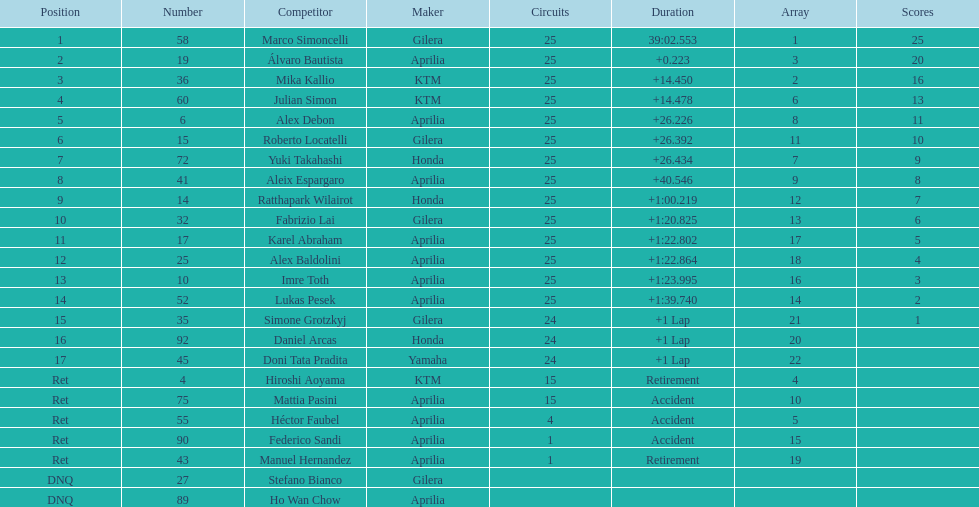I'm looking to parse the entire table for insights. Could you assist me with that? {'header': ['Position', 'Number', 'Competitor', 'Maker', 'Circuits', 'Duration', 'Array', 'Scores'], 'rows': [['1', '58', 'Marco Simoncelli', 'Gilera', '25', '39:02.553', '1', '25'], ['2', '19', 'Álvaro Bautista', 'Aprilia', '25', '+0.223', '3', '20'], ['3', '36', 'Mika Kallio', 'KTM', '25', '+14.450', '2', '16'], ['4', '60', 'Julian Simon', 'KTM', '25', '+14.478', '6', '13'], ['5', '6', 'Alex Debon', 'Aprilia', '25', '+26.226', '8', '11'], ['6', '15', 'Roberto Locatelli', 'Gilera', '25', '+26.392', '11', '10'], ['7', '72', 'Yuki Takahashi', 'Honda', '25', '+26.434', '7', '9'], ['8', '41', 'Aleix Espargaro', 'Aprilia', '25', '+40.546', '9', '8'], ['9', '14', 'Ratthapark Wilairot', 'Honda', '25', '+1:00.219', '12', '7'], ['10', '32', 'Fabrizio Lai', 'Gilera', '25', '+1:20.825', '13', '6'], ['11', '17', 'Karel Abraham', 'Aprilia', '25', '+1:22.802', '17', '5'], ['12', '25', 'Alex Baldolini', 'Aprilia', '25', '+1:22.864', '18', '4'], ['13', '10', 'Imre Toth', 'Aprilia', '25', '+1:23.995', '16', '3'], ['14', '52', 'Lukas Pesek', 'Aprilia', '25', '+1:39.740', '14', '2'], ['15', '35', 'Simone Grotzkyj', 'Gilera', '24', '+1 Lap', '21', '1'], ['16', '92', 'Daniel Arcas', 'Honda', '24', '+1 Lap', '20', ''], ['17', '45', 'Doni Tata Pradita', 'Yamaha', '24', '+1 Lap', '22', ''], ['Ret', '4', 'Hiroshi Aoyama', 'KTM', '15', 'Retirement', '4', ''], ['Ret', '75', 'Mattia Pasini', 'Aprilia', '15', 'Accident', '10', ''], ['Ret', '55', 'Héctor Faubel', 'Aprilia', '4', 'Accident', '5', ''], ['Ret', '90', 'Federico Sandi', 'Aprilia', '1', 'Accident', '15', ''], ['Ret', '43', 'Manuel Hernandez', 'Aprilia', '1', 'Retirement', '19', ''], ['DNQ', '27', 'Stefano Bianco', 'Gilera', '', '', '', ''], ['DNQ', '89', 'Ho Wan Chow', 'Aprilia', '', '', '', '']]} The country with the most riders was Italy. 